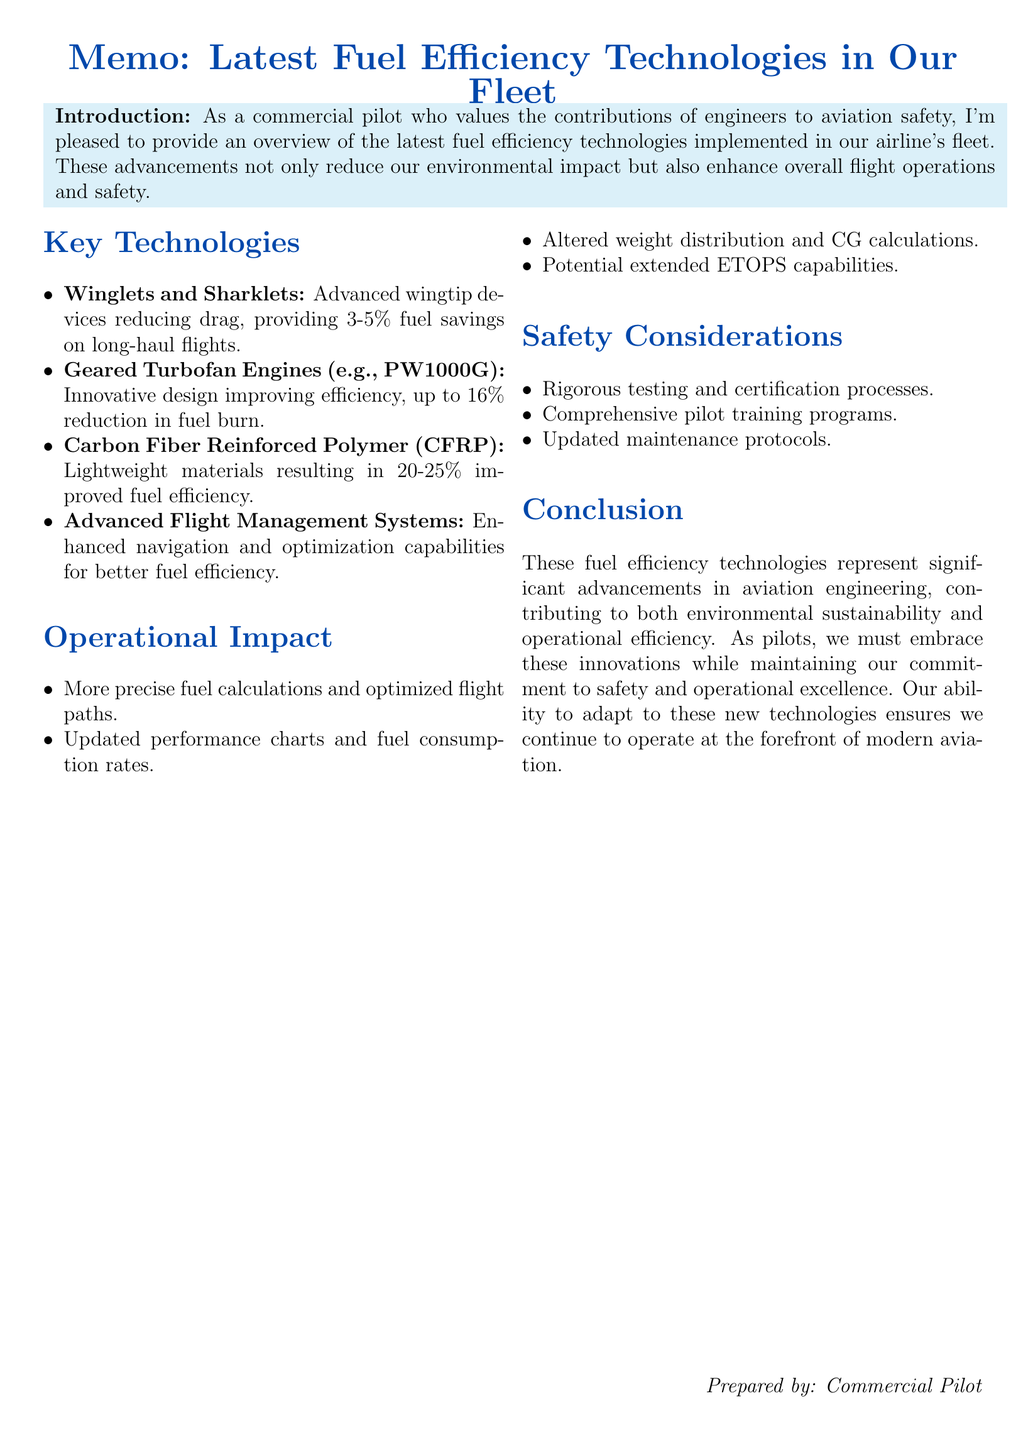What are the latest fuel efficiency technologies? The technologies include Winglets and Sharklets, Geared Turbofan Engines, CFRP Composites, and Advanced Flight Management Systems.
Answer: Winglets and Sharklets, Geared Turbofan Engines, CFRP Composites, Advanced Flight Management Systems What is the fuel savings percentage for Winglets and Sharklets? The document states that Winglets and Sharklets provide approximately 3-5% fuel savings on long-haul flights.
Answer: 3-5% What material contributes to a 20-25% improvement in fuel efficiency? Carbon Fiber Reinforced Polymer (CFRP) Composites are identified as the material leading to this improvement.
Answer: CFRP Composites What is the potential impact of Geared Turbofan Engines on fuel burn? The document specifies that these engines can achieve up to 16% reduction in fuel burn.
Answer: 16% How do new technologies affect flight planning? New technologies allow for more precise fuel calculations and optimized flight paths, potentially reducing contingency fuel requirements.
Answer: More precise fuel calculations What aspect of flight operations may require updated training and procedures? Improved fuel efficiency may allow for extended ETOPS capabilities, which require updated training and procedures.
Answer: Extended ETOPS capabilities What is a key safety consideration for new technologies? New technologies undergo rigorous testing and certification processes to ensure they meet or exceed safety standards.
Answer: Rigorous testing What helps pilots familiarize themselves with new systems? Comprehensive training programs are essential for pilots to adapt to new systems and their impact.
Answer: Comprehensive training programs 